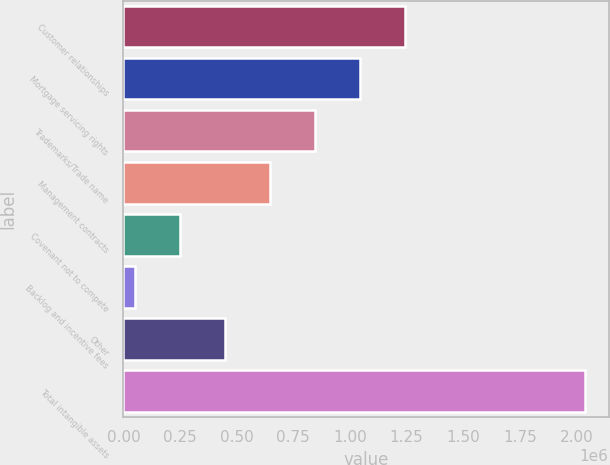Convert chart. <chart><loc_0><loc_0><loc_500><loc_500><bar_chart><fcel>Customer relationships<fcel>Mortgage servicing rights<fcel>Trademarks/Trade name<fcel>Management contracts<fcel>Covenant not to compete<fcel>Backlog and incentive fees<fcel>Other<fcel>Total intangible assets<nl><fcel>1.24369e+06<fcel>1.04469e+06<fcel>845682<fcel>646678<fcel>248671<fcel>49667<fcel>447675<fcel>2.0397e+06<nl></chart> 